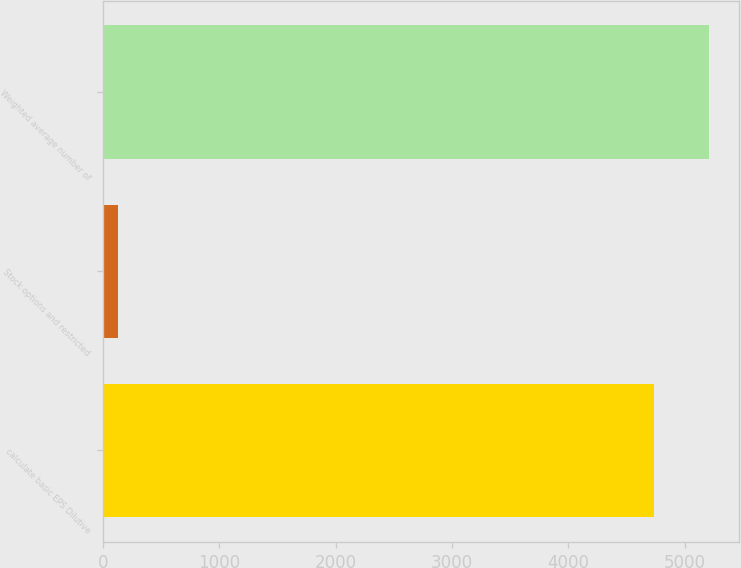Convert chart. <chart><loc_0><loc_0><loc_500><loc_500><bar_chart><fcel>calculate basic EPS Dilutive<fcel>Stock options and restricted<fcel>Weighted average number of<nl><fcel>4737<fcel>125<fcel>5210.7<nl></chart> 